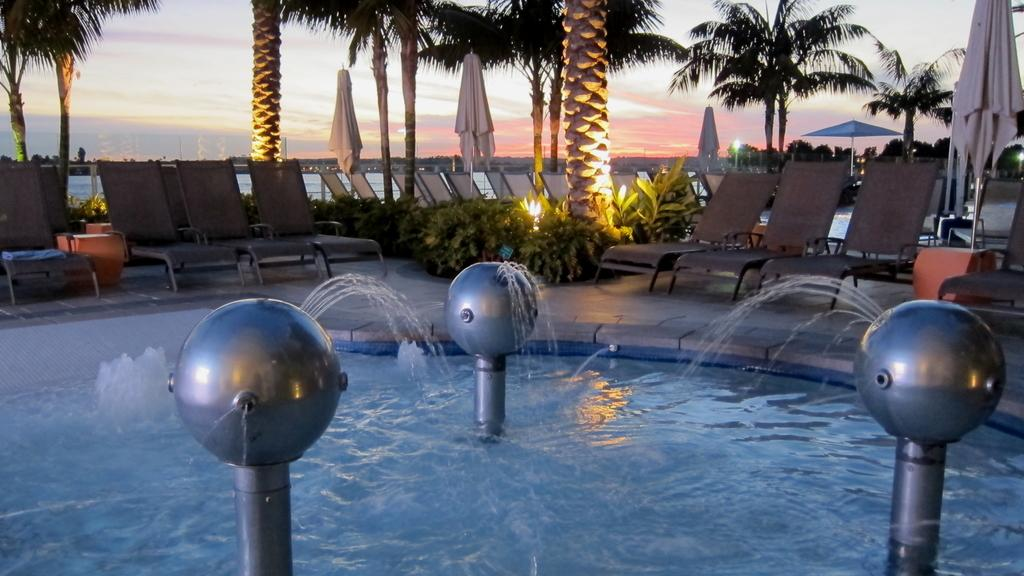What type of furniture can be seen in the image? There are chairs in the image. What type of natural elements are present in the image? There are trees and water visible in the image. What part of the natural environment is visible in the image? The sky is visible in the image. Where is the sister located in the image? There is no sister present in the image. What type of map can be seen in the image? There is no map present in the image. 